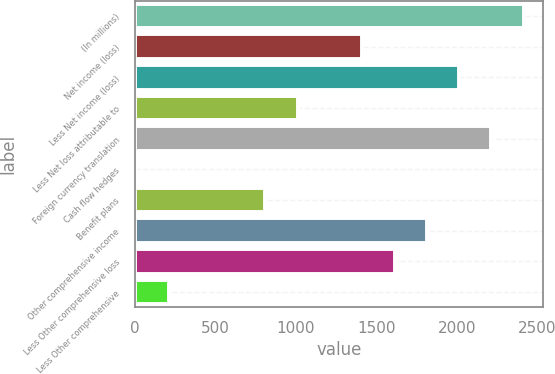Convert chart. <chart><loc_0><loc_0><loc_500><loc_500><bar_chart><fcel>(In millions)<fcel>Net income (loss)<fcel>Less Net income (loss)<fcel>Less Net loss attributable to<fcel>Foreign currency translation<fcel>Cash flow hedges<fcel>Benefit plans<fcel>Other comprehensive income<fcel>Less Other comprehensive loss<fcel>Less Other comprehensive<nl><fcel>2417.6<fcel>1413.6<fcel>2016<fcel>1012<fcel>2216.8<fcel>8<fcel>811.2<fcel>1815.2<fcel>1614.4<fcel>208.8<nl></chart> 